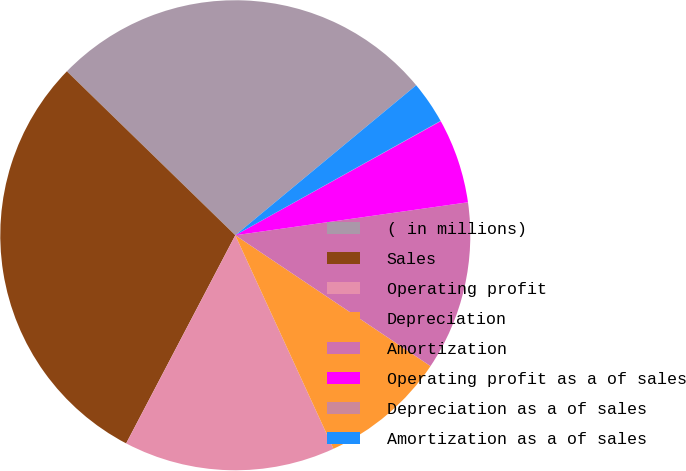Convert chart. <chart><loc_0><loc_0><loc_500><loc_500><pie_chart><fcel>( in millions)<fcel>Sales<fcel>Operating profit<fcel>Depreciation<fcel>Amortization<fcel>Operating profit as a of sales<fcel>Depreciation as a of sales<fcel>Amortization as a of sales<nl><fcel>26.7%<fcel>29.6%<fcel>14.55%<fcel>8.74%<fcel>11.64%<fcel>5.83%<fcel>0.02%<fcel>2.93%<nl></chart> 